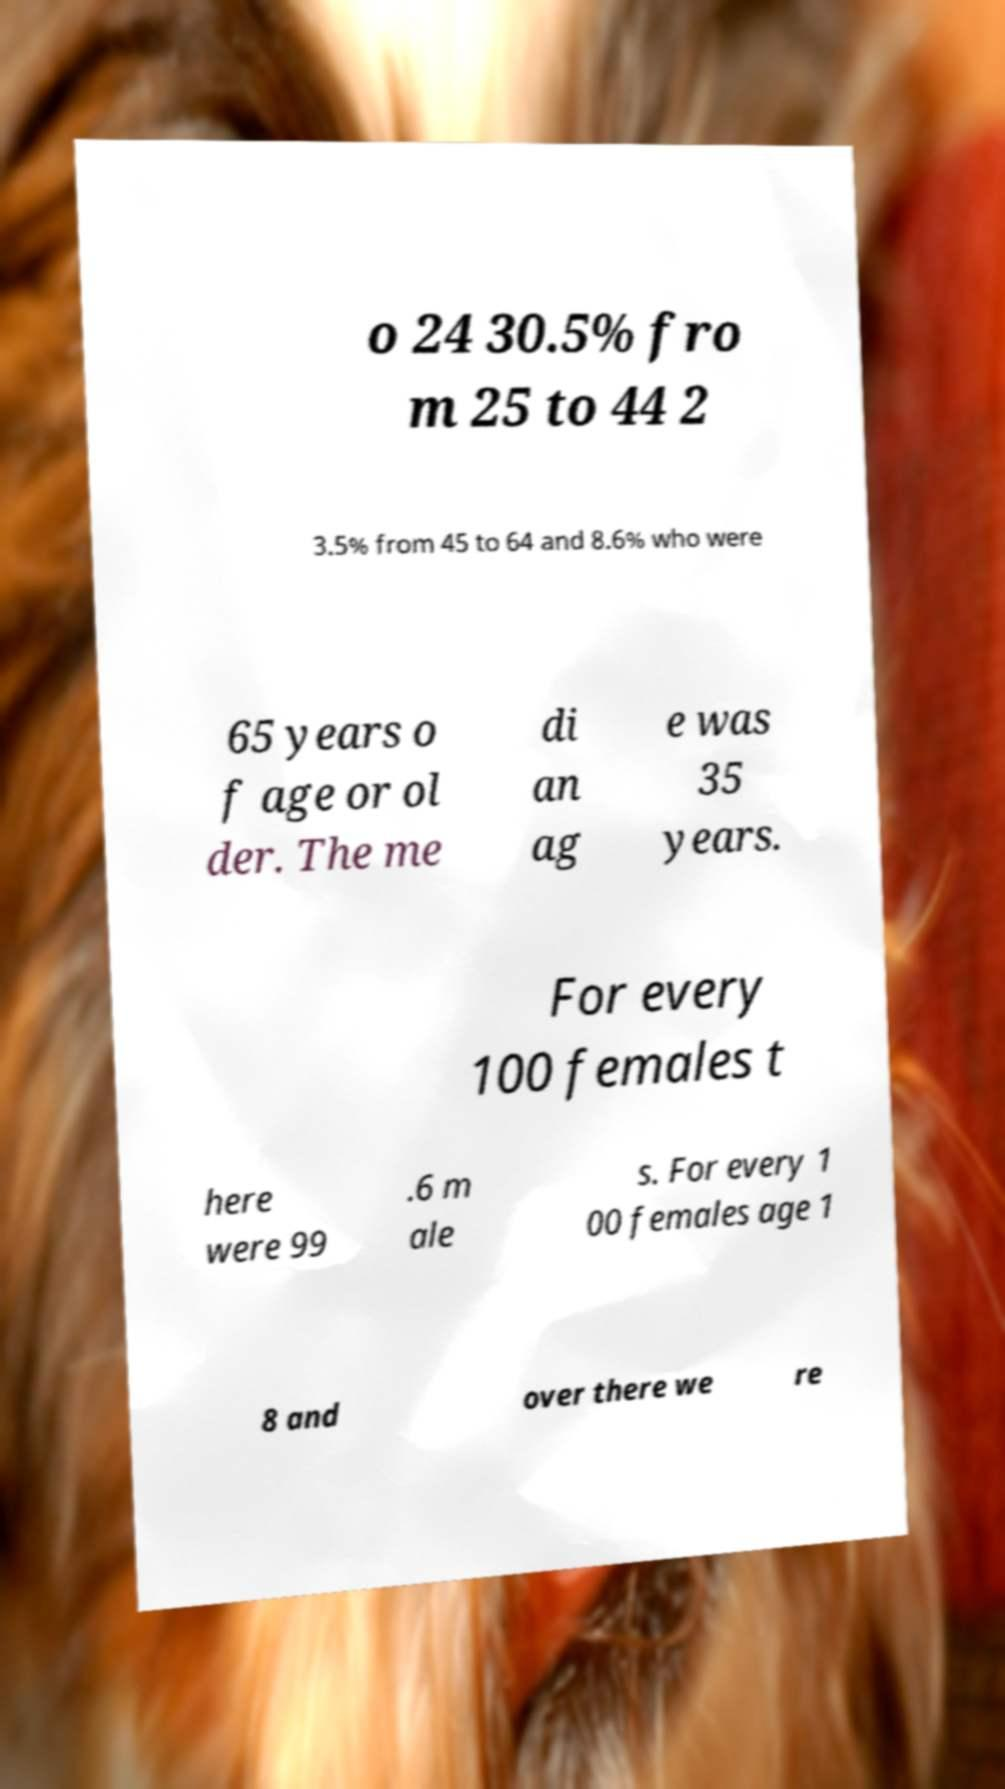Could you assist in decoding the text presented in this image and type it out clearly? o 24 30.5% fro m 25 to 44 2 3.5% from 45 to 64 and 8.6% who were 65 years o f age or ol der. The me di an ag e was 35 years. For every 100 females t here were 99 .6 m ale s. For every 1 00 females age 1 8 and over there we re 